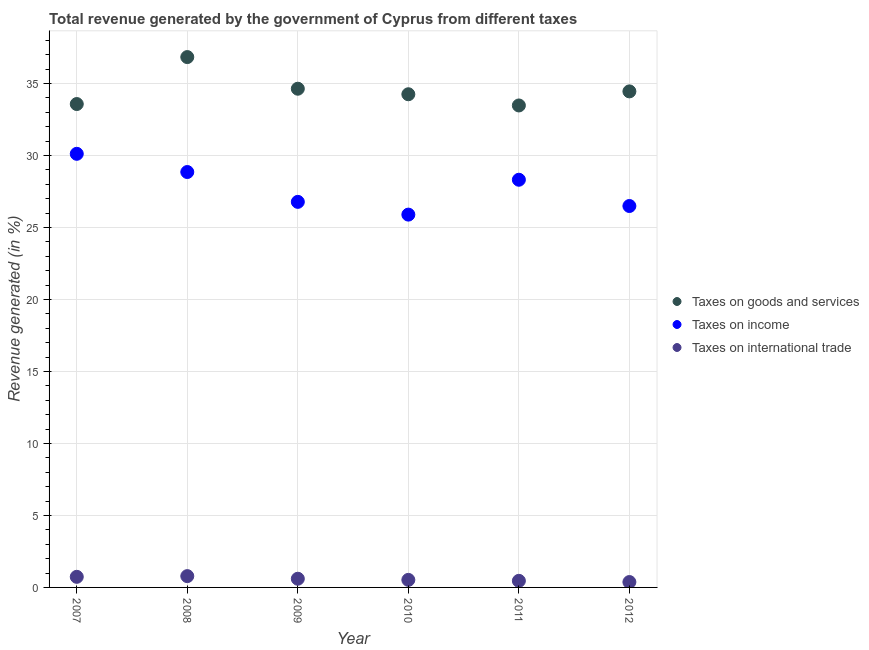What is the percentage of revenue generated by tax on international trade in 2011?
Keep it short and to the point. 0.46. Across all years, what is the maximum percentage of revenue generated by taxes on goods and services?
Offer a very short reply. 36.84. Across all years, what is the minimum percentage of revenue generated by taxes on goods and services?
Offer a terse response. 33.48. In which year was the percentage of revenue generated by taxes on goods and services minimum?
Your answer should be very brief. 2011. What is the total percentage of revenue generated by taxes on income in the graph?
Your response must be concise. 166.47. What is the difference between the percentage of revenue generated by taxes on goods and services in 2007 and that in 2010?
Your answer should be very brief. -0.68. What is the difference between the percentage of revenue generated by tax on international trade in 2007 and the percentage of revenue generated by taxes on goods and services in 2012?
Offer a very short reply. -33.72. What is the average percentage of revenue generated by taxes on income per year?
Your answer should be compact. 27.75. In the year 2008, what is the difference between the percentage of revenue generated by taxes on goods and services and percentage of revenue generated by taxes on income?
Your answer should be compact. 7.99. What is the ratio of the percentage of revenue generated by taxes on goods and services in 2009 to that in 2010?
Your answer should be compact. 1.01. What is the difference between the highest and the second highest percentage of revenue generated by tax on international trade?
Give a very brief answer. 0.05. What is the difference between the highest and the lowest percentage of revenue generated by tax on international trade?
Offer a very short reply. 0.41. In how many years, is the percentage of revenue generated by taxes on income greater than the average percentage of revenue generated by taxes on income taken over all years?
Give a very brief answer. 3. Is the sum of the percentage of revenue generated by tax on international trade in 2008 and 2009 greater than the maximum percentage of revenue generated by taxes on income across all years?
Your answer should be compact. No. Is it the case that in every year, the sum of the percentage of revenue generated by taxes on goods and services and percentage of revenue generated by taxes on income is greater than the percentage of revenue generated by tax on international trade?
Keep it short and to the point. Yes. Does the percentage of revenue generated by taxes on income monotonically increase over the years?
Give a very brief answer. No. Is the percentage of revenue generated by taxes on goods and services strictly greater than the percentage of revenue generated by taxes on income over the years?
Provide a succinct answer. Yes. Is the percentage of revenue generated by taxes on goods and services strictly less than the percentage of revenue generated by tax on international trade over the years?
Ensure brevity in your answer.  No. How many years are there in the graph?
Keep it short and to the point. 6. Where does the legend appear in the graph?
Your response must be concise. Center right. How are the legend labels stacked?
Provide a short and direct response. Vertical. What is the title of the graph?
Provide a succinct answer. Total revenue generated by the government of Cyprus from different taxes. Does "Domestic economy" appear as one of the legend labels in the graph?
Make the answer very short. No. What is the label or title of the X-axis?
Offer a very short reply. Year. What is the label or title of the Y-axis?
Provide a short and direct response. Revenue generated (in %). What is the Revenue generated (in %) of Taxes on goods and services in 2007?
Provide a short and direct response. 33.58. What is the Revenue generated (in %) of Taxes on income in 2007?
Provide a short and direct response. 30.12. What is the Revenue generated (in %) in Taxes on international trade in 2007?
Offer a very short reply. 0.74. What is the Revenue generated (in %) in Taxes on goods and services in 2008?
Your answer should be very brief. 36.84. What is the Revenue generated (in %) of Taxes on income in 2008?
Provide a short and direct response. 28.86. What is the Revenue generated (in %) of Taxes on international trade in 2008?
Keep it short and to the point. 0.79. What is the Revenue generated (in %) of Taxes on goods and services in 2009?
Give a very brief answer. 34.64. What is the Revenue generated (in %) in Taxes on income in 2009?
Offer a very short reply. 26.78. What is the Revenue generated (in %) of Taxes on international trade in 2009?
Your answer should be compact. 0.6. What is the Revenue generated (in %) of Taxes on goods and services in 2010?
Your answer should be compact. 34.26. What is the Revenue generated (in %) of Taxes on income in 2010?
Keep it short and to the point. 25.9. What is the Revenue generated (in %) of Taxes on international trade in 2010?
Provide a succinct answer. 0.52. What is the Revenue generated (in %) in Taxes on goods and services in 2011?
Provide a short and direct response. 33.48. What is the Revenue generated (in %) of Taxes on income in 2011?
Ensure brevity in your answer.  28.32. What is the Revenue generated (in %) in Taxes on international trade in 2011?
Provide a short and direct response. 0.46. What is the Revenue generated (in %) in Taxes on goods and services in 2012?
Offer a very short reply. 34.46. What is the Revenue generated (in %) in Taxes on income in 2012?
Provide a short and direct response. 26.5. What is the Revenue generated (in %) of Taxes on international trade in 2012?
Offer a very short reply. 0.37. Across all years, what is the maximum Revenue generated (in %) in Taxes on goods and services?
Provide a short and direct response. 36.84. Across all years, what is the maximum Revenue generated (in %) in Taxes on income?
Offer a terse response. 30.12. Across all years, what is the maximum Revenue generated (in %) of Taxes on international trade?
Offer a terse response. 0.79. Across all years, what is the minimum Revenue generated (in %) in Taxes on goods and services?
Provide a succinct answer. 33.48. Across all years, what is the minimum Revenue generated (in %) in Taxes on income?
Give a very brief answer. 25.9. Across all years, what is the minimum Revenue generated (in %) in Taxes on international trade?
Keep it short and to the point. 0.37. What is the total Revenue generated (in %) in Taxes on goods and services in the graph?
Offer a very short reply. 207.26. What is the total Revenue generated (in %) in Taxes on income in the graph?
Make the answer very short. 166.47. What is the total Revenue generated (in %) in Taxes on international trade in the graph?
Keep it short and to the point. 3.48. What is the difference between the Revenue generated (in %) of Taxes on goods and services in 2007 and that in 2008?
Provide a succinct answer. -3.26. What is the difference between the Revenue generated (in %) in Taxes on income in 2007 and that in 2008?
Give a very brief answer. 1.27. What is the difference between the Revenue generated (in %) of Taxes on international trade in 2007 and that in 2008?
Provide a succinct answer. -0.05. What is the difference between the Revenue generated (in %) in Taxes on goods and services in 2007 and that in 2009?
Offer a very short reply. -1.06. What is the difference between the Revenue generated (in %) in Taxes on income in 2007 and that in 2009?
Ensure brevity in your answer.  3.34. What is the difference between the Revenue generated (in %) in Taxes on international trade in 2007 and that in 2009?
Keep it short and to the point. 0.13. What is the difference between the Revenue generated (in %) in Taxes on goods and services in 2007 and that in 2010?
Keep it short and to the point. -0.68. What is the difference between the Revenue generated (in %) of Taxes on income in 2007 and that in 2010?
Ensure brevity in your answer.  4.22. What is the difference between the Revenue generated (in %) of Taxes on international trade in 2007 and that in 2010?
Provide a short and direct response. 0.21. What is the difference between the Revenue generated (in %) of Taxes on goods and services in 2007 and that in 2011?
Your response must be concise. 0.1. What is the difference between the Revenue generated (in %) in Taxes on income in 2007 and that in 2011?
Provide a short and direct response. 1.8. What is the difference between the Revenue generated (in %) of Taxes on international trade in 2007 and that in 2011?
Your answer should be compact. 0.28. What is the difference between the Revenue generated (in %) of Taxes on goods and services in 2007 and that in 2012?
Your response must be concise. -0.88. What is the difference between the Revenue generated (in %) of Taxes on income in 2007 and that in 2012?
Your response must be concise. 3.63. What is the difference between the Revenue generated (in %) of Taxes on international trade in 2007 and that in 2012?
Make the answer very short. 0.36. What is the difference between the Revenue generated (in %) in Taxes on goods and services in 2008 and that in 2009?
Offer a terse response. 2.2. What is the difference between the Revenue generated (in %) of Taxes on income in 2008 and that in 2009?
Your answer should be compact. 2.07. What is the difference between the Revenue generated (in %) of Taxes on international trade in 2008 and that in 2009?
Keep it short and to the point. 0.18. What is the difference between the Revenue generated (in %) in Taxes on goods and services in 2008 and that in 2010?
Give a very brief answer. 2.58. What is the difference between the Revenue generated (in %) in Taxes on income in 2008 and that in 2010?
Provide a short and direct response. 2.96. What is the difference between the Revenue generated (in %) of Taxes on international trade in 2008 and that in 2010?
Ensure brevity in your answer.  0.26. What is the difference between the Revenue generated (in %) of Taxes on goods and services in 2008 and that in 2011?
Make the answer very short. 3.36. What is the difference between the Revenue generated (in %) in Taxes on income in 2008 and that in 2011?
Your answer should be compact. 0.54. What is the difference between the Revenue generated (in %) in Taxes on international trade in 2008 and that in 2011?
Keep it short and to the point. 0.33. What is the difference between the Revenue generated (in %) in Taxes on goods and services in 2008 and that in 2012?
Provide a short and direct response. 2.38. What is the difference between the Revenue generated (in %) of Taxes on income in 2008 and that in 2012?
Your answer should be compact. 2.36. What is the difference between the Revenue generated (in %) of Taxes on international trade in 2008 and that in 2012?
Give a very brief answer. 0.41. What is the difference between the Revenue generated (in %) in Taxes on goods and services in 2009 and that in 2010?
Your answer should be very brief. 0.38. What is the difference between the Revenue generated (in %) of Taxes on income in 2009 and that in 2010?
Your answer should be compact. 0.89. What is the difference between the Revenue generated (in %) of Taxes on international trade in 2009 and that in 2010?
Keep it short and to the point. 0.08. What is the difference between the Revenue generated (in %) in Taxes on goods and services in 2009 and that in 2011?
Ensure brevity in your answer.  1.16. What is the difference between the Revenue generated (in %) of Taxes on income in 2009 and that in 2011?
Offer a terse response. -1.54. What is the difference between the Revenue generated (in %) in Taxes on international trade in 2009 and that in 2011?
Ensure brevity in your answer.  0.15. What is the difference between the Revenue generated (in %) of Taxes on goods and services in 2009 and that in 2012?
Ensure brevity in your answer.  0.19. What is the difference between the Revenue generated (in %) in Taxes on income in 2009 and that in 2012?
Make the answer very short. 0.29. What is the difference between the Revenue generated (in %) in Taxes on international trade in 2009 and that in 2012?
Keep it short and to the point. 0.23. What is the difference between the Revenue generated (in %) in Taxes on goods and services in 2010 and that in 2011?
Your response must be concise. 0.78. What is the difference between the Revenue generated (in %) of Taxes on income in 2010 and that in 2011?
Provide a short and direct response. -2.42. What is the difference between the Revenue generated (in %) of Taxes on international trade in 2010 and that in 2011?
Your answer should be compact. 0.07. What is the difference between the Revenue generated (in %) of Taxes on goods and services in 2010 and that in 2012?
Give a very brief answer. -0.2. What is the difference between the Revenue generated (in %) of Taxes on income in 2010 and that in 2012?
Keep it short and to the point. -0.6. What is the difference between the Revenue generated (in %) in Taxes on international trade in 2010 and that in 2012?
Ensure brevity in your answer.  0.15. What is the difference between the Revenue generated (in %) of Taxes on goods and services in 2011 and that in 2012?
Offer a terse response. -0.98. What is the difference between the Revenue generated (in %) of Taxes on income in 2011 and that in 2012?
Your answer should be compact. 1.82. What is the difference between the Revenue generated (in %) in Taxes on international trade in 2011 and that in 2012?
Make the answer very short. 0.08. What is the difference between the Revenue generated (in %) of Taxes on goods and services in 2007 and the Revenue generated (in %) of Taxes on income in 2008?
Provide a succinct answer. 4.72. What is the difference between the Revenue generated (in %) in Taxes on goods and services in 2007 and the Revenue generated (in %) in Taxes on international trade in 2008?
Provide a succinct answer. 32.79. What is the difference between the Revenue generated (in %) in Taxes on income in 2007 and the Revenue generated (in %) in Taxes on international trade in 2008?
Your answer should be compact. 29.34. What is the difference between the Revenue generated (in %) of Taxes on goods and services in 2007 and the Revenue generated (in %) of Taxes on income in 2009?
Your answer should be compact. 6.8. What is the difference between the Revenue generated (in %) in Taxes on goods and services in 2007 and the Revenue generated (in %) in Taxes on international trade in 2009?
Offer a terse response. 32.98. What is the difference between the Revenue generated (in %) in Taxes on income in 2007 and the Revenue generated (in %) in Taxes on international trade in 2009?
Offer a very short reply. 29.52. What is the difference between the Revenue generated (in %) in Taxes on goods and services in 2007 and the Revenue generated (in %) in Taxes on income in 2010?
Make the answer very short. 7.68. What is the difference between the Revenue generated (in %) in Taxes on goods and services in 2007 and the Revenue generated (in %) in Taxes on international trade in 2010?
Give a very brief answer. 33.05. What is the difference between the Revenue generated (in %) of Taxes on income in 2007 and the Revenue generated (in %) of Taxes on international trade in 2010?
Make the answer very short. 29.6. What is the difference between the Revenue generated (in %) of Taxes on goods and services in 2007 and the Revenue generated (in %) of Taxes on income in 2011?
Your answer should be very brief. 5.26. What is the difference between the Revenue generated (in %) of Taxes on goods and services in 2007 and the Revenue generated (in %) of Taxes on international trade in 2011?
Provide a succinct answer. 33.12. What is the difference between the Revenue generated (in %) in Taxes on income in 2007 and the Revenue generated (in %) in Taxes on international trade in 2011?
Keep it short and to the point. 29.66. What is the difference between the Revenue generated (in %) of Taxes on goods and services in 2007 and the Revenue generated (in %) of Taxes on income in 2012?
Your response must be concise. 7.08. What is the difference between the Revenue generated (in %) of Taxes on goods and services in 2007 and the Revenue generated (in %) of Taxes on international trade in 2012?
Ensure brevity in your answer.  33.2. What is the difference between the Revenue generated (in %) in Taxes on income in 2007 and the Revenue generated (in %) in Taxes on international trade in 2012?
Make the answer very short. 29.75. What is the difference between the Revenue generated (in %) of Taxes on goods and services in 2008 and the Revenue generated (in %) of Taxes on income in 2009?
Ensure brevity in your answer.  10.06. What is the difference between the Revenue generated (in %) in Taxes on goods and services in 2008 and the Revenue generated (in %) in Taxes on international trade in 2009?
Make the answer very short. 36.24. What is the difference between the Revenue generated (in %) of Taxes on income in 2008 and the Revenue generated (in %) of Taxes on international trade in 2009?
Your response must be concise. 28.25. What is the difference between the Revenue generated (in %) of Taxes on goods and services in 2008 and the Revenue generated (in %) of Taxes on income in 2010?
Make the answer very short. 10.94. What is the difference between the Revenue generated (in %) in Taxes on goods and services in 2008 and the Revenue generated (in %) in Taxes on international trade in 2010?
Make the answer very short. 36.32. What is the difference between the Revenue generated (in %) in Taxes on income in 2008 and the Revenue generated (in %) in Taxes on international trade in 2010?
Provide a succinct answer. 28.33. What is the difference between the Revenue generated (in %) of Taxes on goods and services in 2008 and the Revenue generated (in %) of Taxes on income in 2011?
Provide a succinct answer. 8.52. What is the difference between the Revenue generated (in %) of Taxes on goods and services in 2008 and the Revenue generated (in %) of Taxes on international trade in 2011?
Your response must be concise. 36.38. What is the difference between the Revenue generated (in %) in Taxes on income in 2008 and the Revenue generated (in %) in Taxes on international trade in 2011?
Give a very brief answer. 28.4. What is the difference between the Revenue generated (in %) in Taxes on goods and services in 2008 and the Revenue generated (in %) in Taxes on income in 2012?
Your answer should be compact. 10.35. What is the difference between the Revenue generated (in %) of Taxes on goods and services in 2008 and the Revenue generated (in %) of Taxes on international trade in 2012?
Provide a short and direct response. 36.47. What is the difference between the Revenue generated (in %) in Taxes on income in 2008 and the Revenue generated (in %) in Taxes on international trade in 2012?
Give a very brief answer. 28.48. What is the difference between the Revenue generated (in %) of Taxes on goods and services in 2009 and the Revenue generated (in %) of Taxes on income in 2010?
Make the answer very short. 8.75. What is the difference between the Revenue generated (in %) in Taxes on goods and services in 2009 and the Revenue generated (in %) in Taxes on international trade in 2010?
Provide a short and direct response. 34.12. What is the difference between the Revenue generated (in %) of Taxes on income in 2009 and the Revenue generated (in %) of Taxes on international trade in 2010?
Your answer should be very brief. 26.26. What is the difference between the Revenue generated (in %) in Taxes on goods and services in 2009 and the Revenue generated (in %) in Taxes on income in 2011?
Give a very brief answer. 6.32. What is the difference between the Revenue generated (in %) of Taxes on goods and services in 2009 and the Revenue generated (in %) of Taxes on international trade in 2011?
Offer a very short reply. 34.19. What is the difference between the Revenue generated (in %) in Taxes on income in 2009 and the Revenue generated (in %) in Taxes on international trade in 2011?
Provide a succinct answer. 26.33. What is the difference between the Revenue generated (in %) of Taxes on goods and services in 2009 and the Revenue generated (in %) of Taxes on income in 2012?
Offer a terse response. 8.15. What is the difference between the Revenue generated (in %) of Taxes on goods and services in 2009 and the Revenue generated (in %) of Taxes on international trade in 2012?
Ensure brevity in your answer.  34.27. What is the difference between the Revenue generated (in %) in Taxes on income in 2009 and the Revenue generated (in %) in Taxes on international trade in 2012?
Offer a terse response. 26.41. What is the difference between the Revenue generated (in %) in Taxes on goods and services in 2010 and the Revenue generated (in %) in Taxes on income in 2011?
Keep it short and to the point. 5.94. What is the difference between the Revenue generated (in %) in Taxes on goods and services in 2010 and the Revenue generated (in %) in Taxes on international trade in 2011?
Ensure brevity in your answer.  33.8. What is the difference between the Revenue generated (in %) of Taxes on income in 2010 and the Revenue generated (in %) of Taxes on international trade in 2011?
Provide a succinct answer. 25.44. What is the difference between the Revenue generated (in %) of Taxes on goods and services in 2010 and the Revenue generated (in %) of Taxes on income in 2012?
Give a very brief answer. 7.76. What is the difference between the Revenue generated (in %) in Taxes on goods and services in 2010 and the Revenue generated (in %) in Taxes on international trade in 2012?
Offer a very short reply. 33.88. What is the difference between the Revenue generated (in %) in Taxes on income in 2010 and the Revenue generated (in %) in Taxes on international trade in 2012?
Provide a succinct answer. 25.52. What is the difference between the Revenue generated (in %) in Taxes on goods and services in 2011 and the Revenue generated (in %) in Taxes on income in 2012?
Keep it short and to the point. 6.98. What is the difference between the Revenue generated (in %) in Taxes on goods and services in 2011 and the Revenue generated (in %) in Taxes on international trade in 2012?
Your answer should be very brief. 33.11. What is the difference between the Revenue generated (in %) in Taxes on income in 2011 and the Revenue generated (in %) in Taxes on international trade in 2012?
Your answer should be very brief. 27.95. What is the average Revenue generated (in %) in Taxes on goods and services per year?
Make the answer very short. 34.54. What is the average Revenue generated (in %) of Taxes on income per year?
Provide a succinct answer. 27.75. What is the average Revenue generated (in %) of Taxes on international trade per year?
Your answer should be very brief. 0.58. In the year 2007, what is the difference between the Revenue generated (in %) of Taxes on goods and services and Revenue generated (in %) of Taxes on income?
Provide a short and direct response. 3.46. In the year 2007, what is the difference between the Revenue generated (in %) in Taxes on goods and services and Revenue generated (in %) in Taxes on international trade?
Make the answer very short. 32.84. In the year 2007, what is the difference between the Revenue generated (in %) in Taxes on income and Revenue generated (in %) in Taxes on international trade?
Make the answer very short. 29.38. In the year 2008, what is the difference between the Revenue generated (in %) in Taxes on goods and services and Revenue generated (in %) in Taxes on income?
Offer a terse response. 7.99. In the year 2008, what is the difference between the Revenue generated (in %) in Taxes on goods and services and Revenue generated (in %) in Taxes on international trade?
Make the answer very short. 36.06. In the year 2008, what is the difference between the Revenue generated (in %) of Taxes on income and Revenue generated (in %) of Taxes on international trade?
Offer a terse response. 28.07. In the year 2009, what is the difference between the Revenue generated (in %) in Taxes on goods and services and Revenue generated (in %) in Taxes on income?
Make the answer very short. 7.86. In the year 2009, what is the difference between the Revenue generated (in %) of Taxes on goods and services and Revenue generated (in %) of Taxes on international trade?
Your response must be concise. 34.04. In the year 2009, what is the difference between the Revenue generated (in %) of Taxes on income and Revenue generated (in %) of Taxes on international trade?
Your response must be concise. 26.18. In the year 2010, what is the difference between the Revenue generated (in %) of Taxes on goods and services and Revenue generated (in %) of Taxes on income?
Your answer should be compact. 8.36. In the year 2010, what is the difference between the Revenue generated (in %) of Taxes on goods and services and Revenue generated (in %) of Taxes on international trade?
Ensure brevity in your answer.  33.73. In the year 2010, what is the difference between the Revenue generated (in %) of Taxes on income and Revenue generated (in %) of Taxes on international trade?
Make the answer very short. 25.37. In the year 2011, what is the difference between the Revenue generated (in %) in Taxes on goods and services and Revenue generated (in %) in Taxes on income?
Give a very brief answer. 5.16. In the year 2011, what is the difference between the Revenue generated (in %) of Taxes on goods and services and Revenue generated (in %) of Taxes on international trade?
Ensure brevity in your answer.  33.02. In the year 2011, what is the difference between the Revenue generated (in %) of Taxes on income and Revenue generated (in %) of Taxes on international trade?
Ensure brevity in your answer.  27.86. In the year 2012, what is the difference between the Revenue generated (in %) in Taxes on goods and services and Revenue generated (in %) in Taxes on income?
Your answer should be compact. 7.96. In the year 2012, what is the difference between the Revenue generated (in %) in Taxes on goods and services and Revenue generated (in %) in Taxes on international trade?
Offer a very short reply. 34.08. In the year 2012, what is the difference between the Revenue generated (in %) of Taxes on income and Revenue generated (in %) of Taxes on international trade?
Keep it short and to the point. 26.12. What is the ratio of the Revenue generated (in %) of Taxes on goods and services in 2007 to that in 2008?
Give a very brief answer. 0.91. What is the ratio of the Revenue generated (in %) of Taxes on income in 2007 to that in 2008?
Provide a succinct answer. 1.04. What is the ratio of the Revenue generated (in %) of Taxes on international trade in 2007 to that in 2008?
Provide a succinct answer. 0.94. What is the ratio of the Revenue generated (in %) in Taxes on goods and services in 2007 to that in 2009?
Offer a terse response. 0.97. What is the ratio of the Revenue generated (in %) of Taxes on income in 2007 to that in 2009?
Your response must be concise. 1.12. What is the ratio of the Revenue generated (in %) in Taxes on international trade in 2007 to that in 2009?
Offer a terse response. 1.22. What is the ratio of the Revenue generated (in %) in Taxes on goods and services in 2007 to that in 2010?
Make the answer very short. 0.98. What is the ratio of the Revenue generated (in %) of Taxes on income in 2007 to that in 2010?
Offer a terse response. 1.16. What is the ratio of the Revenue generated (in %) of Taxes on international trade in 2007 to that in 2010?
Keep it short and to the point. 1.41. What is the ratio of the Revenue generated (in %) in Taxes on income in 2007 to that in 2011?
Make the answer very short. 1.06. What is the ratio of the Revenue generated (in %) in Taxes on international trade in 2007 to that in 2011?
Make the answer very short. 1.61. What is the ratio of the Revenue generated (in %) of Taxes on goods and services in 2007 to that in 2012?
Keep it short and to the point. 0.97. What is the ratio of the Revenue generated (in %) of Taxes on income in 2007 to that in 2012?
Keep it short and to the point. 1.14. What is the ratio of the Revenue generated (in %) in Taxes on international trade in 2007 to that in 2012?
Your answer should be very brief. 1.97. What is the ratio of the Revenue generated (in %) in Taxes on goods and services in 2008 to that in 2009?
Keep it short and to the point. 1.06. What is the ratio of the Revenue generated (in %) of Taxes on income in 2008 to that in 2009?
Offer a terse response. 1.08. What is the ratio of the Revenue generated (in %) in Taxes on international trade in 2008 to that in 2009?
Offer a very short reply. 1.3. What is the ratio of the Revenue generated (in %) in Taxes on goods and services in 2008 to that in 2010?
Provide a succinct answer. 1.08. What is the ratio of the Revenue generated (in %) of Taxes on income in 2008 to that in 2010?
Your answer should be compact. 1.11. What is the ratio of the Revenue generated (in %) of Taxes on international trade in 2008 to that in 2010?
Offer a terse response. 1.5. What is the ratio of the Revenue generated (in %) in Taxes on goods and services in 2008 to that in 2011?
Provide a short and direct response. 1.1. What is the ratio of the Revenue generated (in %) in Taxes on income in 2008 to that in 2011?
Your answer should be very brief. 1.02. What is the ratio of the Revenue generated (in %) of Taxes on international trade in 2008 to that in 2011?
Provide a succinct answer. 1.72. What is the ratio of the Revenue generated (in %) in Taxes on goods and services in 2008 to that in 2012?
Provide a succinct answer. 1.07. What is the ratio of the Revenue generated (in %) in Taxes on income in 2008 to that in 2012?
Offer a terse response. 1.09. What is the ratio of the Revenue generated (in %) of Taxes on international trade in 2008 to that in 2012?
Keep it short and to the point. 2.1. What is the ratio of the Revenue generated (in %) of Taxes on goods and services in 2009 to that in 2010?
Offer a very short reply. 1.01. What is the ratio of the Revenue generated (in %) of Taxes on income in 2009 to that in 2010?
Ensure brevity in your answer.  1.03. What is the ratio of the Revenue generated (in %) in Taxes on international trade in 2009 to that in 2010?
Give a very brief answer. 1.15. What is the ratio of the Revenue generated (in %) of Taxes on goods and services in 2009 to that in 2011?
Provide a short and direct response. 1.03. What is the ratio of the Revenue generated (in %) of Taxes on income in 2009 to that in 2011?
Offer a terse response. 0.95. What is the ratio of the Revenue generated (in %) of Taxes on international trade in 2009 to that in 2011?
Your response must be concise. 1.32. What is the ratio of the Revenue generated (in %) of Taxes on goods and services in 2009 to that in 2012?
Provide a succinct answer. 1.01. What is the ratio of the Revenue generated (in %) of Taxes on income in 2009 to that in 2012?
Make the answer very short. 1.01. What is the ratio of the Revenue generated (in %) of Taxes on international trade in 2009 to that in 2012?
Provide a short and direct response. 1.61. What is the ratio of the Revenue generated (in %) of Taxes on goods and services in 2010 to that in 2011?
Your answer should be compact. 1.02. What is the ratio of the Revenue generated (in %) in Taxes on income in 2010 to that in 2011?
Keep it short and to the point. 0.91. What is the ratio of the Revenue generated (in %) in Taxes on international trade in 2010 to that in 2011?
Your answer should be compact. 1.15. What is the ratio of the Revenue generated (in %) of Taxes on income in 2010 to that in 2012?
Make the answer very short. 0.98. What is the ratio of the Revenue generated (in %) in Taxes on international trade in 2010 to that in 2012?
Provide a succinct answer. 1.4. What is the ratio of the Revenue generated (in %) of Taxes on goods and services in 2011 to that in 2012?
Keep it short and to the point. 0.97. What is the ratio of the Revenue generated (in %) in Taxes on income in 2011 to that in 2012?
Offer a terse response. 1.07. What is the ratio of the Revenue generated (in %) in Taxes on international trade in 2011 to that in 2012?
Provide a short and direct response. 1.22. What is the difference between the highest and the second highest Revenue generated (in %) of Taxes on goods and services?
Offer a terse response. 2.2. What is the difference between the highest and the second highest Revenue generated (in %) in Taxes on income?
Provide a succinct answer. 1.27. What is the difference between the highest and the second highest Revenue generated (in %) of Taxes on international trade?
Provide a succinct answer. 0.05. What is the difference between the highest and the lowest Revenue generated (in %) in Taxes on goods and services?
Your response must be concise. 3.36. What is the difference between the highest and the lowest Revenue generated (in %) in Taxes on income?
Make the answer very short. 4.22. What is the difference between the highest and the lowest Revenue generated (in %) of Taxes on international trade?
Offer a very short reply. 0.41. 